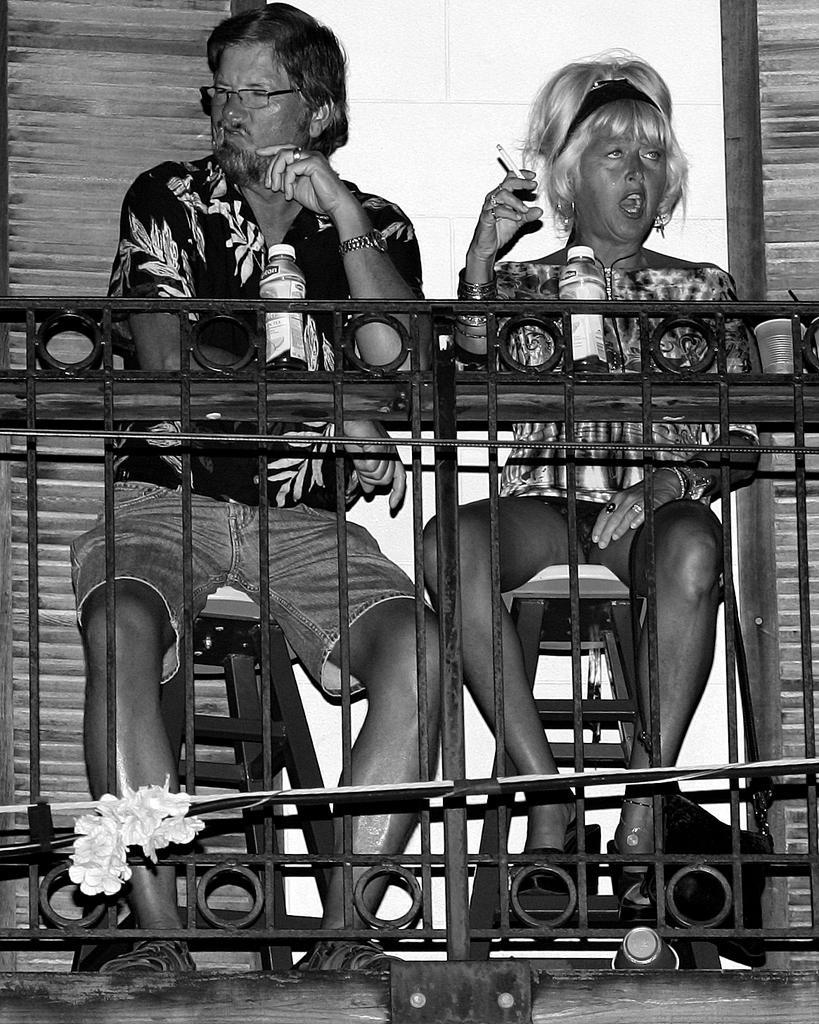Please provide a concise description of this image. In this image I can see the black and white picture in which I can see the railing, a flower pot with flowers, few water bottles, a cup and a man and a woman sitting on stools. In the background I can see the wall which is white in color. 